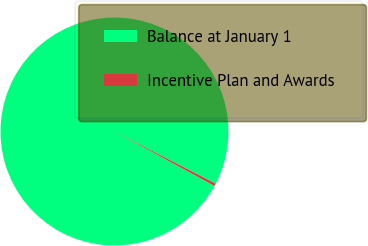<chart> <loc_0><loc_0><loc_500><loc_500><pie_chart><fcel>Balance at January 1<fcel>Incentive Plan and Awards<nl><fcel>99.64%<fcel>0.36%<nl></chart> 